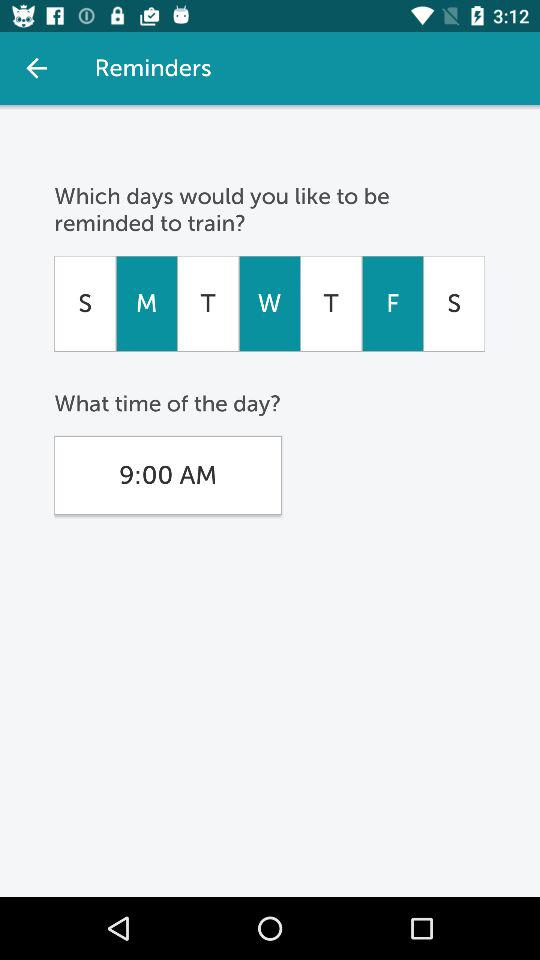What time is selected for a reminder to train? The selected time is 9 a.m. 